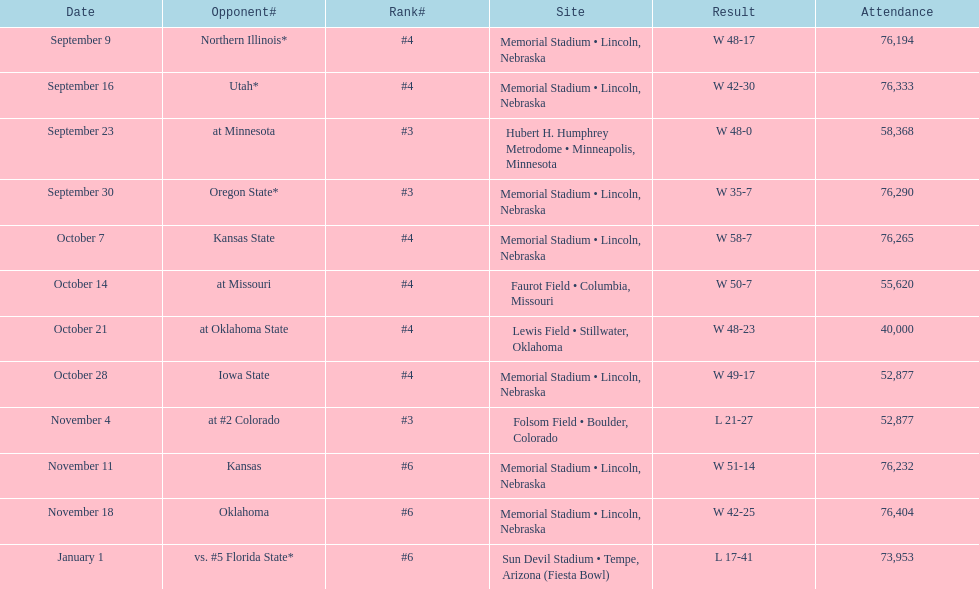When is the inaugural game scheduled? September 9. 